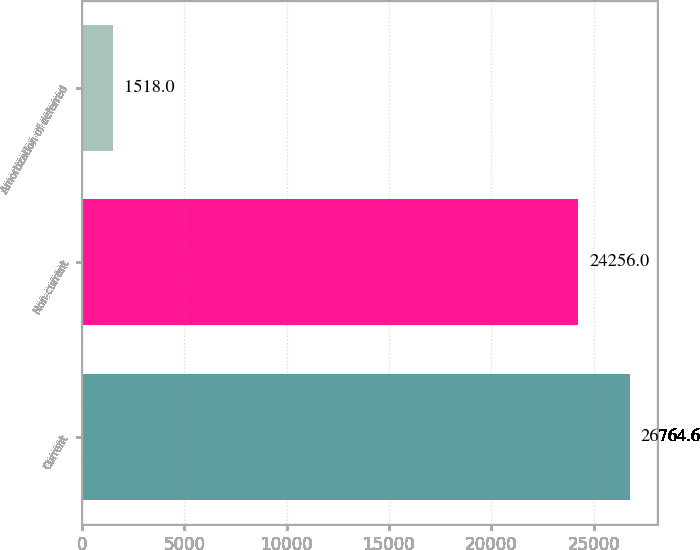Convert chart. <chart><loc_0><loc_0><loc_500><loc_500><bar_chart><fcel>Current<fcel>Non-current<fcel>Amortization of deferred<nl><fcel>26764.6<fcel>24256<fcel>1518<nl></chart> 